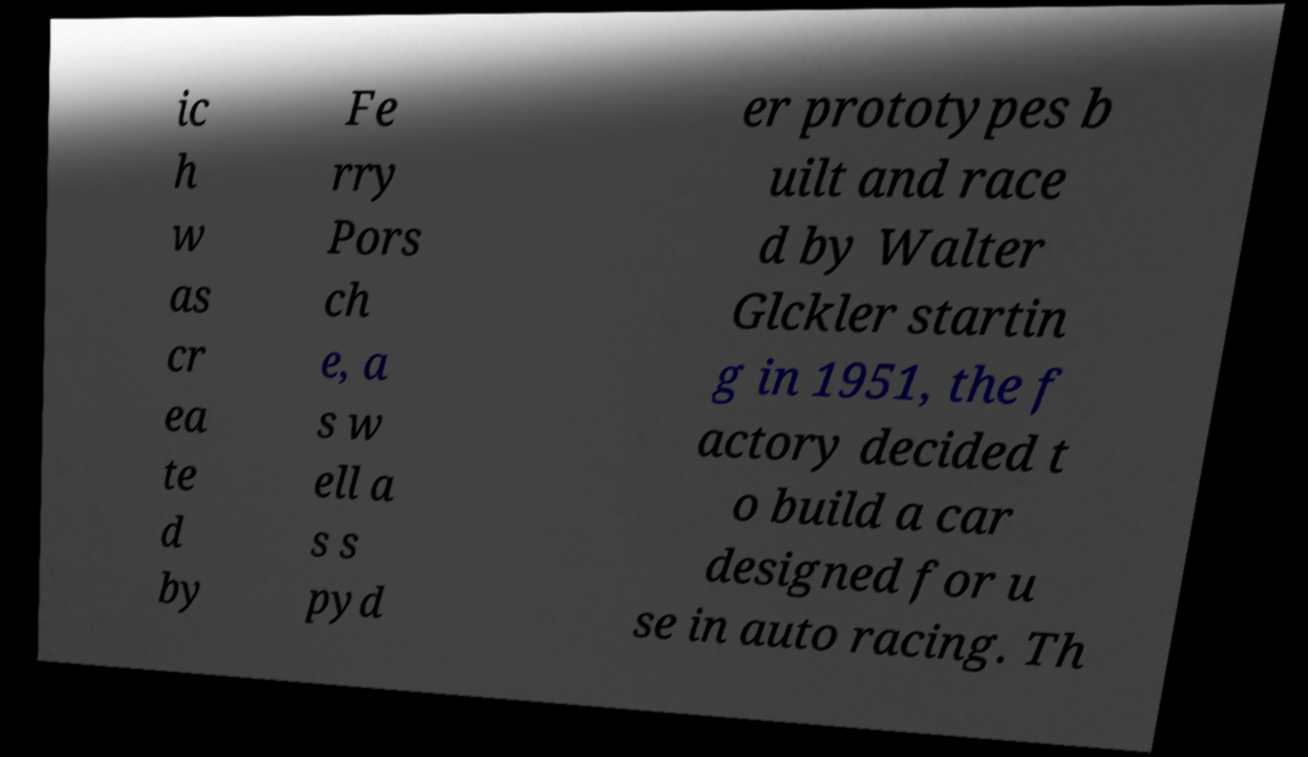For documentation purposes, I need the text within this image transcribed. Could you provide that? ic h w as cr ea te d by Fe rry Pors ch e, a s w ell a s s pyd er prototypes b uilt and race d by Walter Glckler startin g in 1951, the f actory decided t o build a car designed for u se in auto racing. Th 